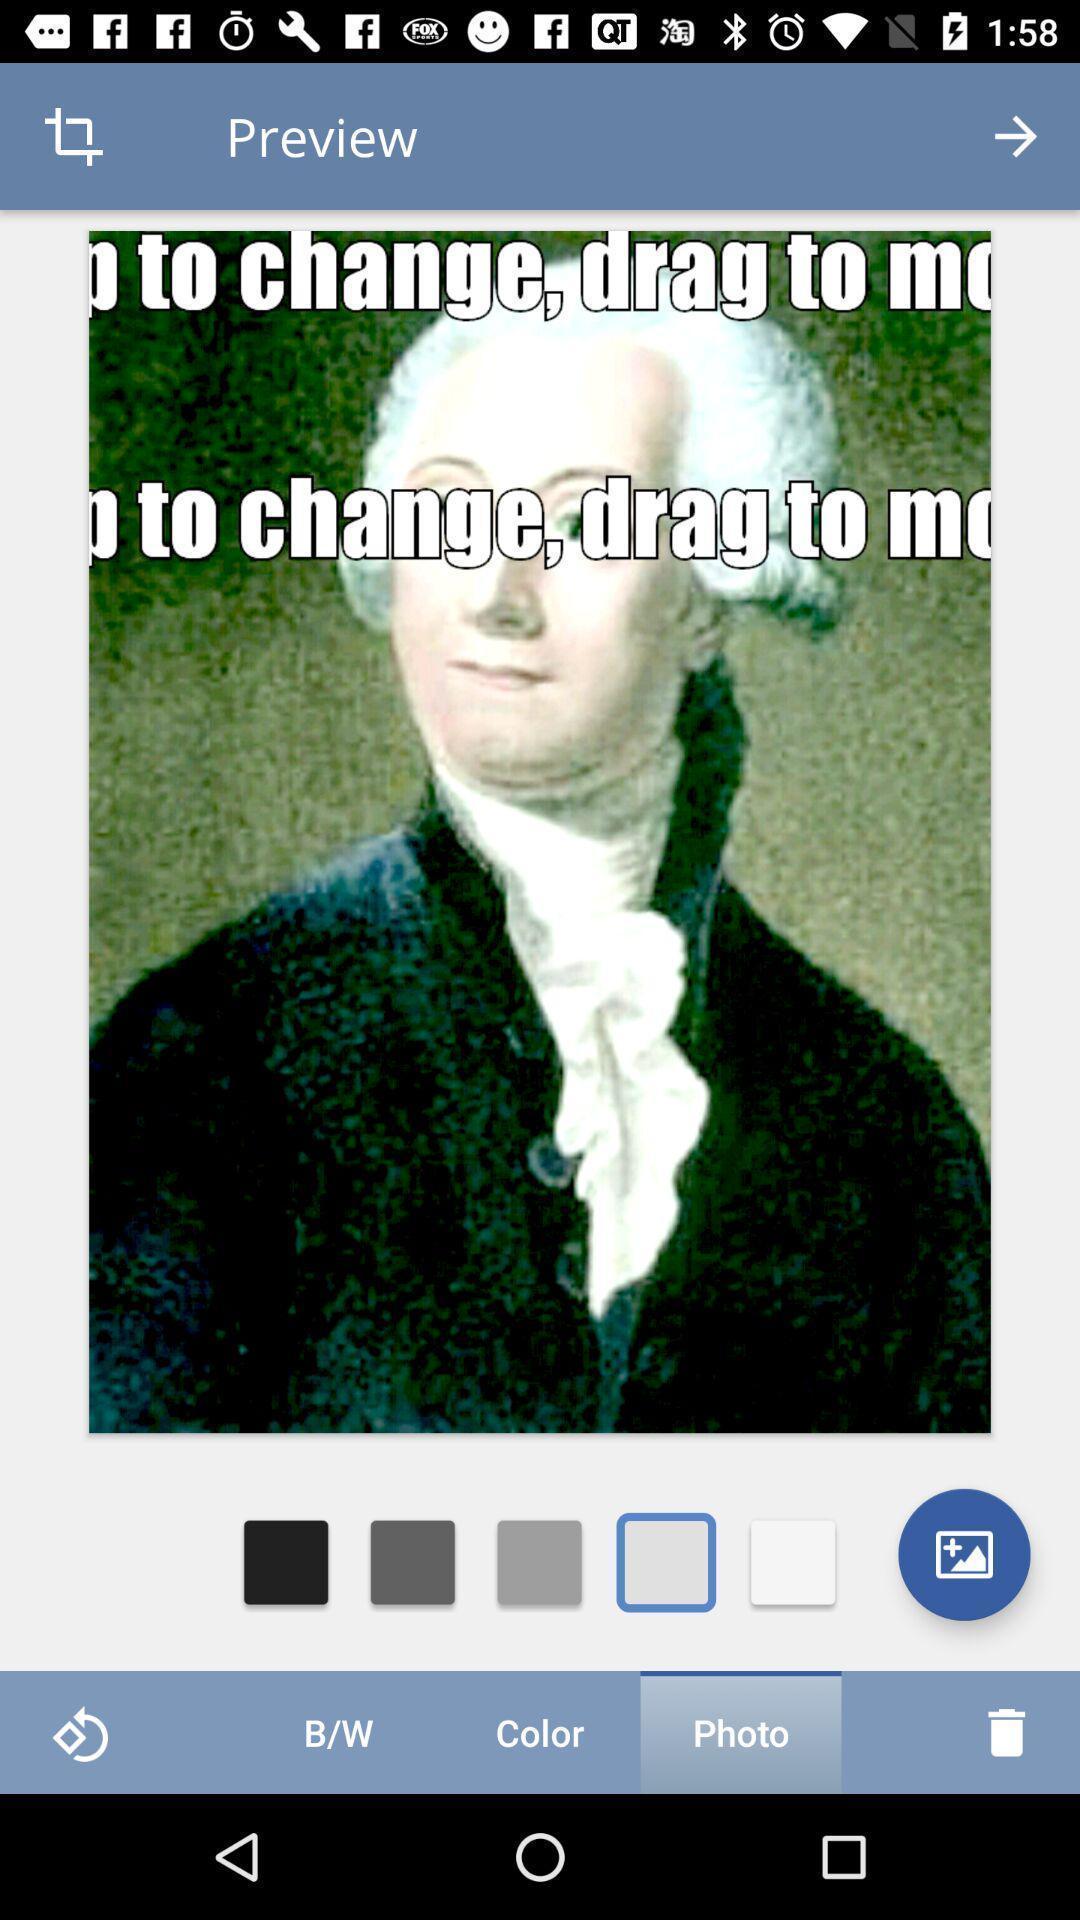Summarize the main components in this picture. Screen shows a picture to be editted. 